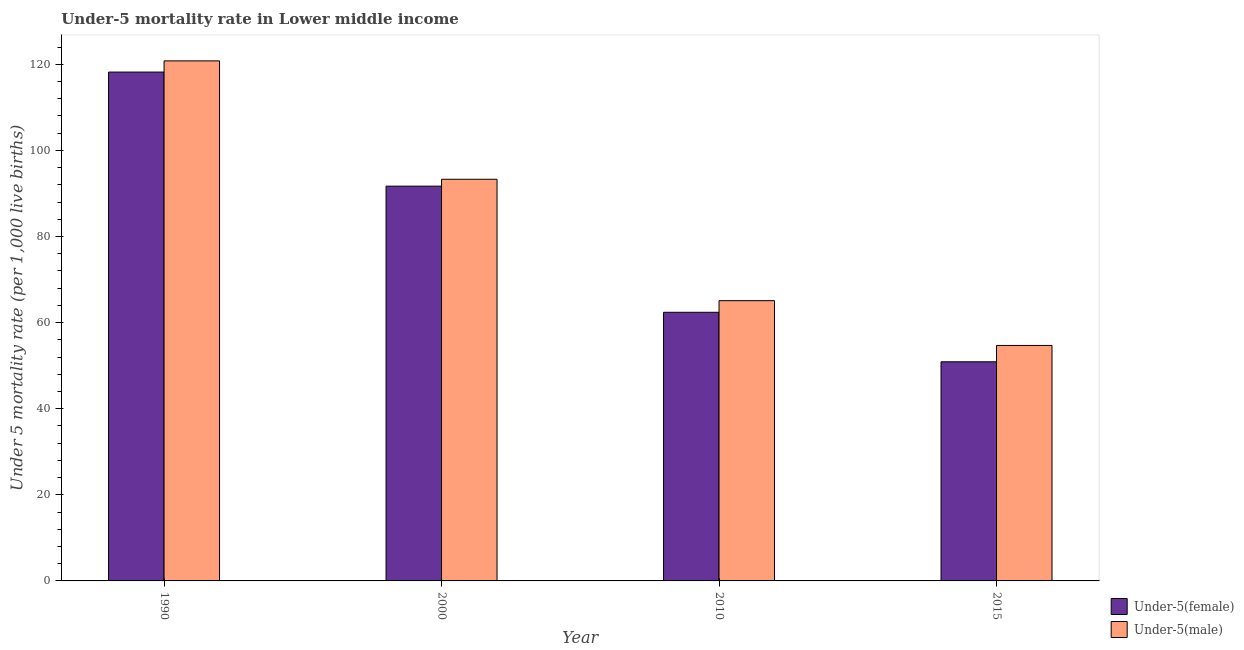How many groups of bars are there?
Keep it short and to the point. 4. Are the number of bars on each tick of the X-axis equal?
Provide a short and direct response. Yes. How many bars are there on the 3rd tick from the left?
Offer a very short reply. 2. What is the label of the 4th group of bars from the left?
Provide a succinct answer. 2015. What is the under-5 female mortality rate in 2015?
Make the answer very short. 50.9. Across all years, what is the maximum under-5 female mortality rate?
Your answer should be compact. 118.2. Across all years, what is the minimum under-5 female mortality rate?
Ensure brevity in your answer.  50.9. In which year was the under-5 female mortality rate minimum?
Provide a short and direct response. 2015. What is the total under-5 female mortality rate in the graph?
Make the answer very short. 323.2. What is the difference between the under-5 female mortality rate in 2000 and that in 2010?
Your answer should be compact. 29.3. What is the difference between the under-5 female mortality rate in 2015 and the under-5 male mortality rate in 2000?
Ensure brevity in your answer.  -40.8. What is the average under-5 male mortality rate per year?
Make the answer very short. 83.47. What is the ratio of the under-5 female mortality rate in 1990 to that in 2000?
Give a very brief answer. 1.29. Is the under-5 male mortality rate in 1990 less than that in 2015?
Offer a terse response. No. What is the difference between the highest and the lowest under-5 male mortality rate?
Offer a terse response. 66.1. In how many years, is the under-5 male mortality rate greater than the average under-5 male mortality rate taken over all years?
Ensure brevity in your answer.  2. Is the sum of the under-5 male mortality rate in 1990 and 2010 greater than the maximum under-5 female mortality rate across all years?
Your answer should be compact. Yes. What does the 2nd bar from the left in 1990 represents?
Your response must be concise. Under-5(male). What does the 2nd bar from the right in 2010 represents?
Provide a short and direct response. Under-5(female). How many bars are there?
Provide a succinct answer. 8. How many years are there in the graph?
Provide a short and direct response. 4. Are the values on the major ticks of Y-axis written in scientific E-notation?
Your answer should be compact. No. Does the graph contain any zero values?
Your answer should be compact. No. How many legend labels are there?
Give a very brief answer. 2. What is the title of the graph?
Your answer should be compact. Under-5 mortality rate in Lower middle income. Does "Fixed telephone" appear as one of the legend labels in the graph?
Offer a very short reply. No. What is the label or title of the Y-axis?
Keep it short and to the point. Under 5 mortality rate (per 1,0 live births). What is the Under 5 mortality rate (per 1,000 live births) of Under-5(female) in 1990?
Give a very brief answer. 118.2. What is the Under 5 mortality rate (per 1,000 live births) in Under-5(male) in 1990?
Provide a short and direct response. 120.8. What is the Under 5 mortality rate (per 1,000 live births) in Under-5(female) in 2000?
Give a very brief answer. 91.7. What is the Under 5 mortality rate (per 1,000 live births) in Under-5(male) in 2000?
Provide a succinct answer. 93.3. What is the Under 5 mortality rate (per 1,000 live births) in Under-5(female) in 2010?
Your answer should be very brief. 62.4. What is the Under 5 mortality rate (per 1,000 live births) in Under-5(male) in 2010?
Offer a terse response. 65.1. What is the Under 5 mortality rate (per 1,000 live births) of Under-5(female) in 2015?
Provide a short and direct response. 50.9. What is the Under 5 mortality rate (per 1,000 live births) of Under-5(male) in 2015?
Provide a succinct answer. 54.7. Across all years, what is the maximum Under 5 mortality rate (per 1,000 live births) of Under-5(female)?
Your answer should be compact. 118.2. Across all years, what is the maximum Under 5 mortality rate (per 1,000 live births) of Under-5(male)?
Offer a very short reply. 120.8. Across all years, what is the minimum Under 5 mortality rate (per 1,000 live births) in Under-5(female)?
Your answer should be very brief. 50.9. Across all years, what is the minimum Under 5 mortality rate (per 1,000 live births) of Under-5(male)?
Offer a very short reply. 54.7. What is the total Under 5 mortality rate (per 1,000 live births) in Under-5(female) in the graph?
Make the answer very short. 323.2. What is the total Under 5 mortality rate (per 1,000 live births) of Under-5(male) in the graph?
Your answer should be compact. 333.9. What is the difference between the Under 5 mortality rate (per 1,000 live births) in Under-5(female) in 1990 and that in 2000?
Provide a short and direct response. 26.5. What is the difference between the Under 5 mortality rate (per 1,000 live births) in Under-5(male) in 1990 and that in 2000?
Offer a very short reply. 27.5. What is the difference between the Under 5 mortality rate (per 1,000 live births) in Under-5(female) in 1990 and that in 2010?
Your answer should be compact. 55.8. What is the difference between the Under 5 mortality rate (per 1,000 live births) of Under-5(male) in 1990 and that in 2010?
Make the answer very short. 55.7. What is the difference between the Under 5 mortality rate (per 1,000 live births) of Under-5(female) in 1990 and that in 2015?
Your answer should be very brief. 67.3. What is the difference between the Under 5 mortality rate (per 1,000 live births) in Under-5(male) in 1990 and that in 2015?
Provide a short and direct response. 66.1. What is the difference between the Under 5 mortality rate (per 1,000 live births) in Under-5(female) in 2000 and that in 2010?
Provide a short and direct response. 29.3. What is the difference between the Under 5 mortality rate (per 1,000 live births) in Under-5(male) in 2000 and that in 2010?
Give a very brief answer. 28.2. What is the difference between the Under 5 mortality rate (per 1,000 live births) in Under-5(female) in 2000 and that in 2015?
Your response must be concise. 40.8. What is the difference between the Under 5 mortality rate (per 1,000 live births) in Under-5(male) in 2000 and that in 2015?
Offer a very short reply. 38.6. What is the difference between the Under 5 mortality rate (per 1,000 live births) in Under-5(female) in 1990 and the Under 5 mortality rate (per 1,000 live births) in Under-5(male) in 2000?
Ensure brevity in your answer.  24.9. What is the difference between the Under 5 mortality rate (per 1,000 live births) of Under-5(female) in 1990 and the Under 5 mortality rate (per 1,000 live births) of Under-5(male) in 2010?
Offer a very short reply. 53.1. What is the difference between the Under 5 mortality rate (per 1,000 live births) in Under-5(female) in 1990 and the Under 5 mortality rate (per 1,000 live births) in Under-5(male) in 2015?
Your response must be concise. 63.5. What is the difference between the Under 5 mortality rate (per 1,000 live births) in Under-5(female) in 2000 and the Under 5 mortality rate (per 1,000 live births) in Under-5(male) in 2010?
Ensure brevity in your answer.  26.6. What is the difference between the Under 5 mortality rate (per 1,000 live births) in Under-5(female) in 2010 and the Under 5 mortality rate (per 1,000 live births) in Under-5(male) in 2015?
Give a very brief answer. 7.7. What is the average Under 5 mortality rate (per 1,000 live births) of Under-5(female) per year?
Your answer should be very brief. 80.8. What is the average Under 5 mortality rate (per 1,000 live births) of Under-5(male) per year?
Provide a succinct answer. 83.47. In the year 2000, what is the difference between the Under 5 mortality rate (per 1,000 live births) of Under-5(female) and Under 5 mortality rate (per 1,000 live births) of Under-5(male)?
Provide a short and direct response. -1.6. In the year 2015, what is the difference between the Under 5 mortality rate (per 1,000 live births) in Under-5(female) and Under 5 mortality rate (per 1,000 live births) in Under-5(male)?
Your answer should be very brief. -3.8. What is the ratio of the Under 5 mortality rate (per 1,000 live births) in Under-5(female) in 1990 to that in 2000?
Provide a short and direct response. 1.29. What is the ratio of the Under 5 mortality rate (per 1,000 live births) in Under-5(male) in 1990 to that in 2000?
Your answer should be compact. 1.29. What is the ratio of the Under 5 mortality rate (per 1,000 live births) of Under-5(female) in 1990 to that in 2010?
Provide a succinct answer. 1.89. What is the ratio of the Under 5 mortality rate (per 1,000 live births) of Under-5(male) in 1990 to that in 2010?
Your answer should be very brief. 1.86. What is the ratio of the Under 5 mortality rate (per 1,000 live births) in Under-5(female) in 1990 to that in 2015?
Your answer should be very brief. 2.32. What is the ratio of the Under 5 mortality rate (per 1,000 live births) in Under-5(male) in 1990 to that in 2015?
Offer a terse response. 2.21. What is the ratio of the Under 5 mortality rate (per 1,000 live births) in Under-5(female) in 2000 to that in 2010?
Your answer should be compact. 1.47. What is the ratio of the Under 5 mortality rate (per 1,000 live births) in Under-5(male) in 2000 to that in 2010?
Provide a succinct answer. 1.43. What is the ratio of the Under 5 mortality rate (per 1,000 live births) in Under-5(female) in 2000 to that in 2015?
Provide a succinct answer. 1.8. What is the ratio of the Under 5 mortality rate (per 1,000 live births) in Under-5(male) in 2000 to that in 2015?
Keep it short and to the point. 1.71. What is the ratio of the Under 5 mortality rate (per 1,000 live births) of Under-5(female) in 2010 to that in 2015?
Make the answer very short. 1.23. What is the ratio of the Under 5 mortality rate (per 1,000 live births) in Under-5(male) in 2010 to that in 2015?
Make the answer very short. 1.19. What is the difference between the highest and the second highest Under 5 mortality rate (per 1,000 live births) in Under-5(male)?
Your answer should be compact. 27.5. What is the difference between the highest and the lowest Under 5 mortality rate (per 1,000 live births) in Under-5(female)?
Your answer should be very brief. 67.3. What is the difference between the highest and the lowest Under 5 mortality rate (per 1,000 live births) in Under-5(male)?
Ensure brevity in your answer.  66.1. 